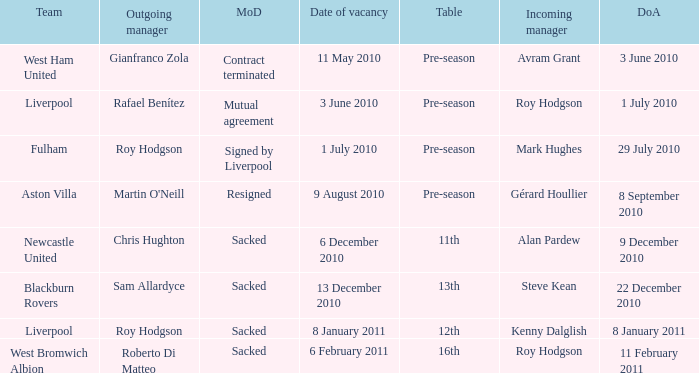How many incoming managers were there after Roy Hodgson left the position for the Fulham team? 1.0. 